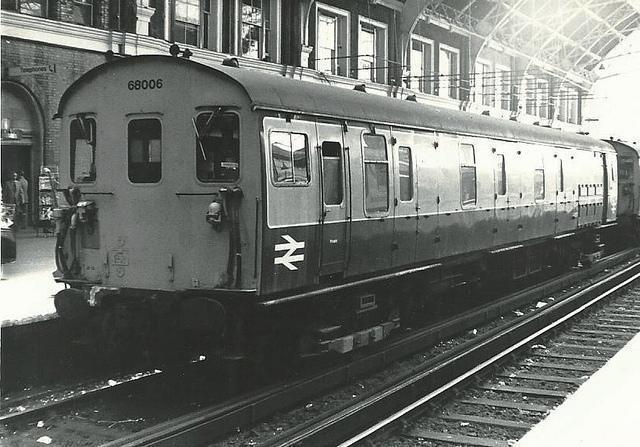What type of building is this?
Make your selection from the four choices given to correctly answer the question.
Options: Hospital, school, library, station. Station. 